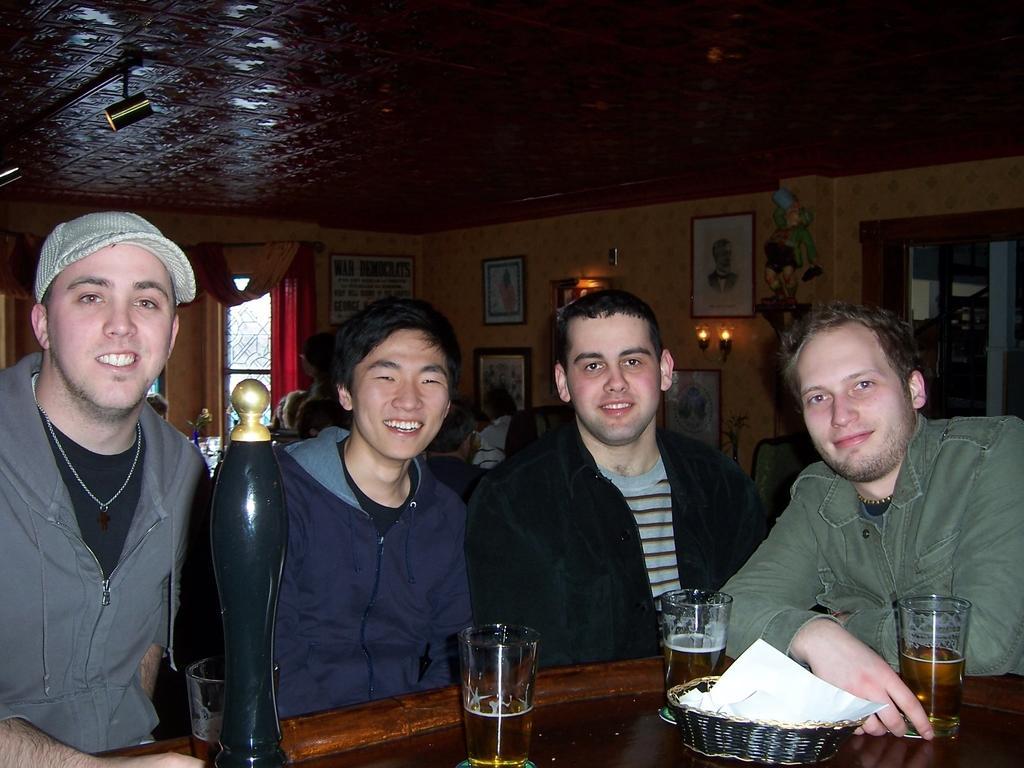How would you summarize this image in a sentence or two? Here we can see four men with glass of beers on the table present in front of them laughing 